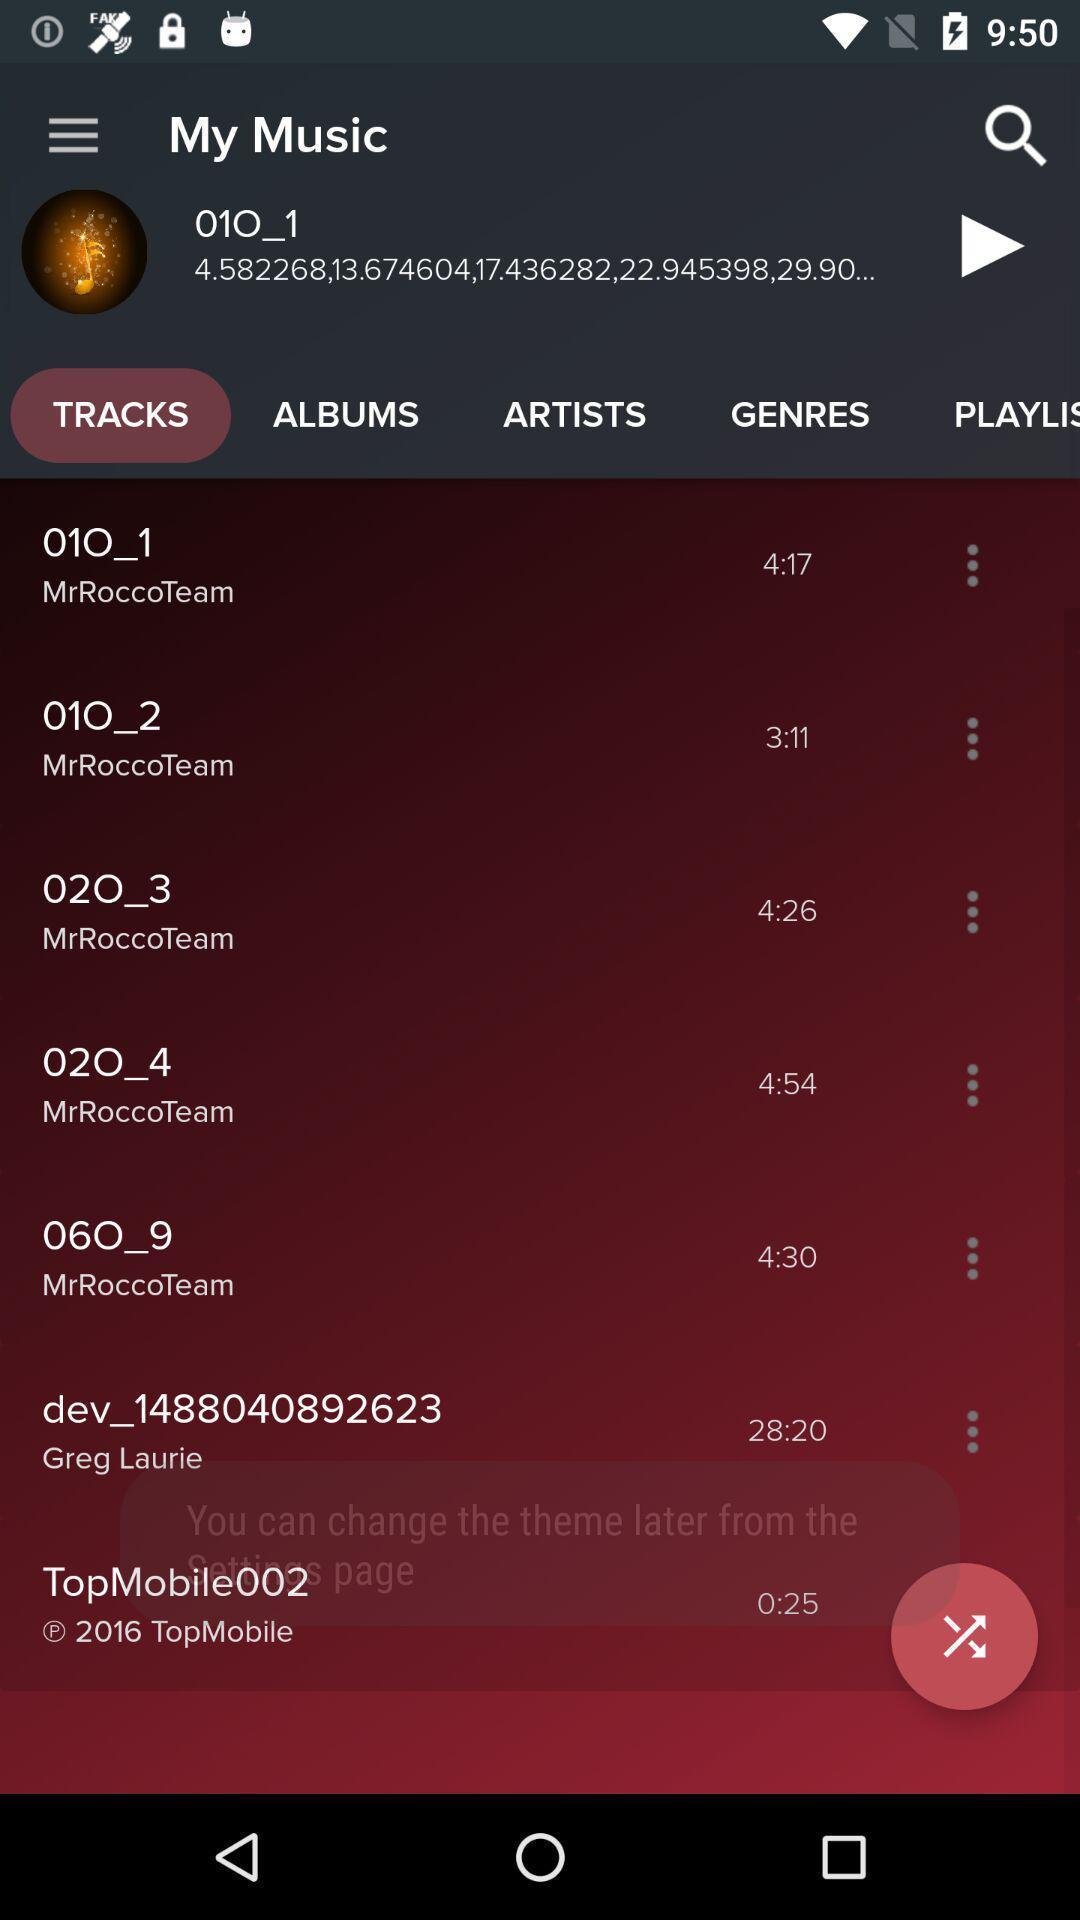What details can you identify in this image? Screen showing tracks in an music application. 